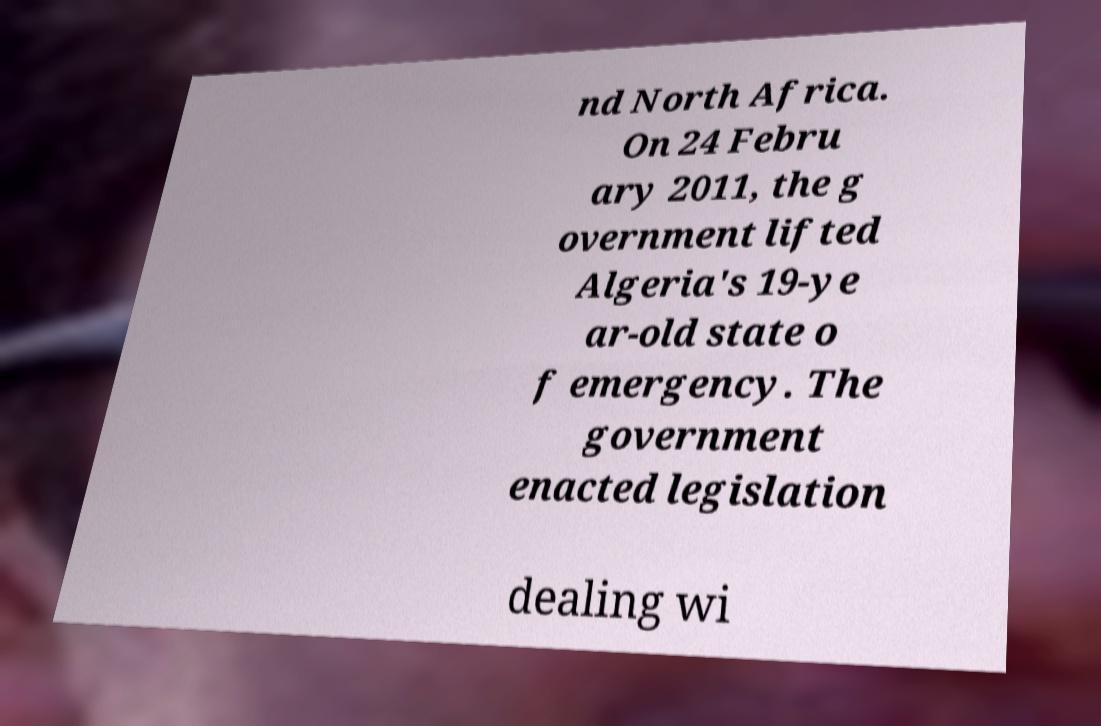What messages or text are displayed in this image? I need them in a readable, typed format. nd North Africa. On 24 Febru ary 2011, the g overnment lifted Algeria's 19-ye ar-old state o f emergency. The government enacted legislation dealing wi 